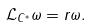<formula> <loc_0><loc_0><loc_500><loc_500>\mathcal { L } _ { C ^ { * } } \omega = r \omega .</formula> 